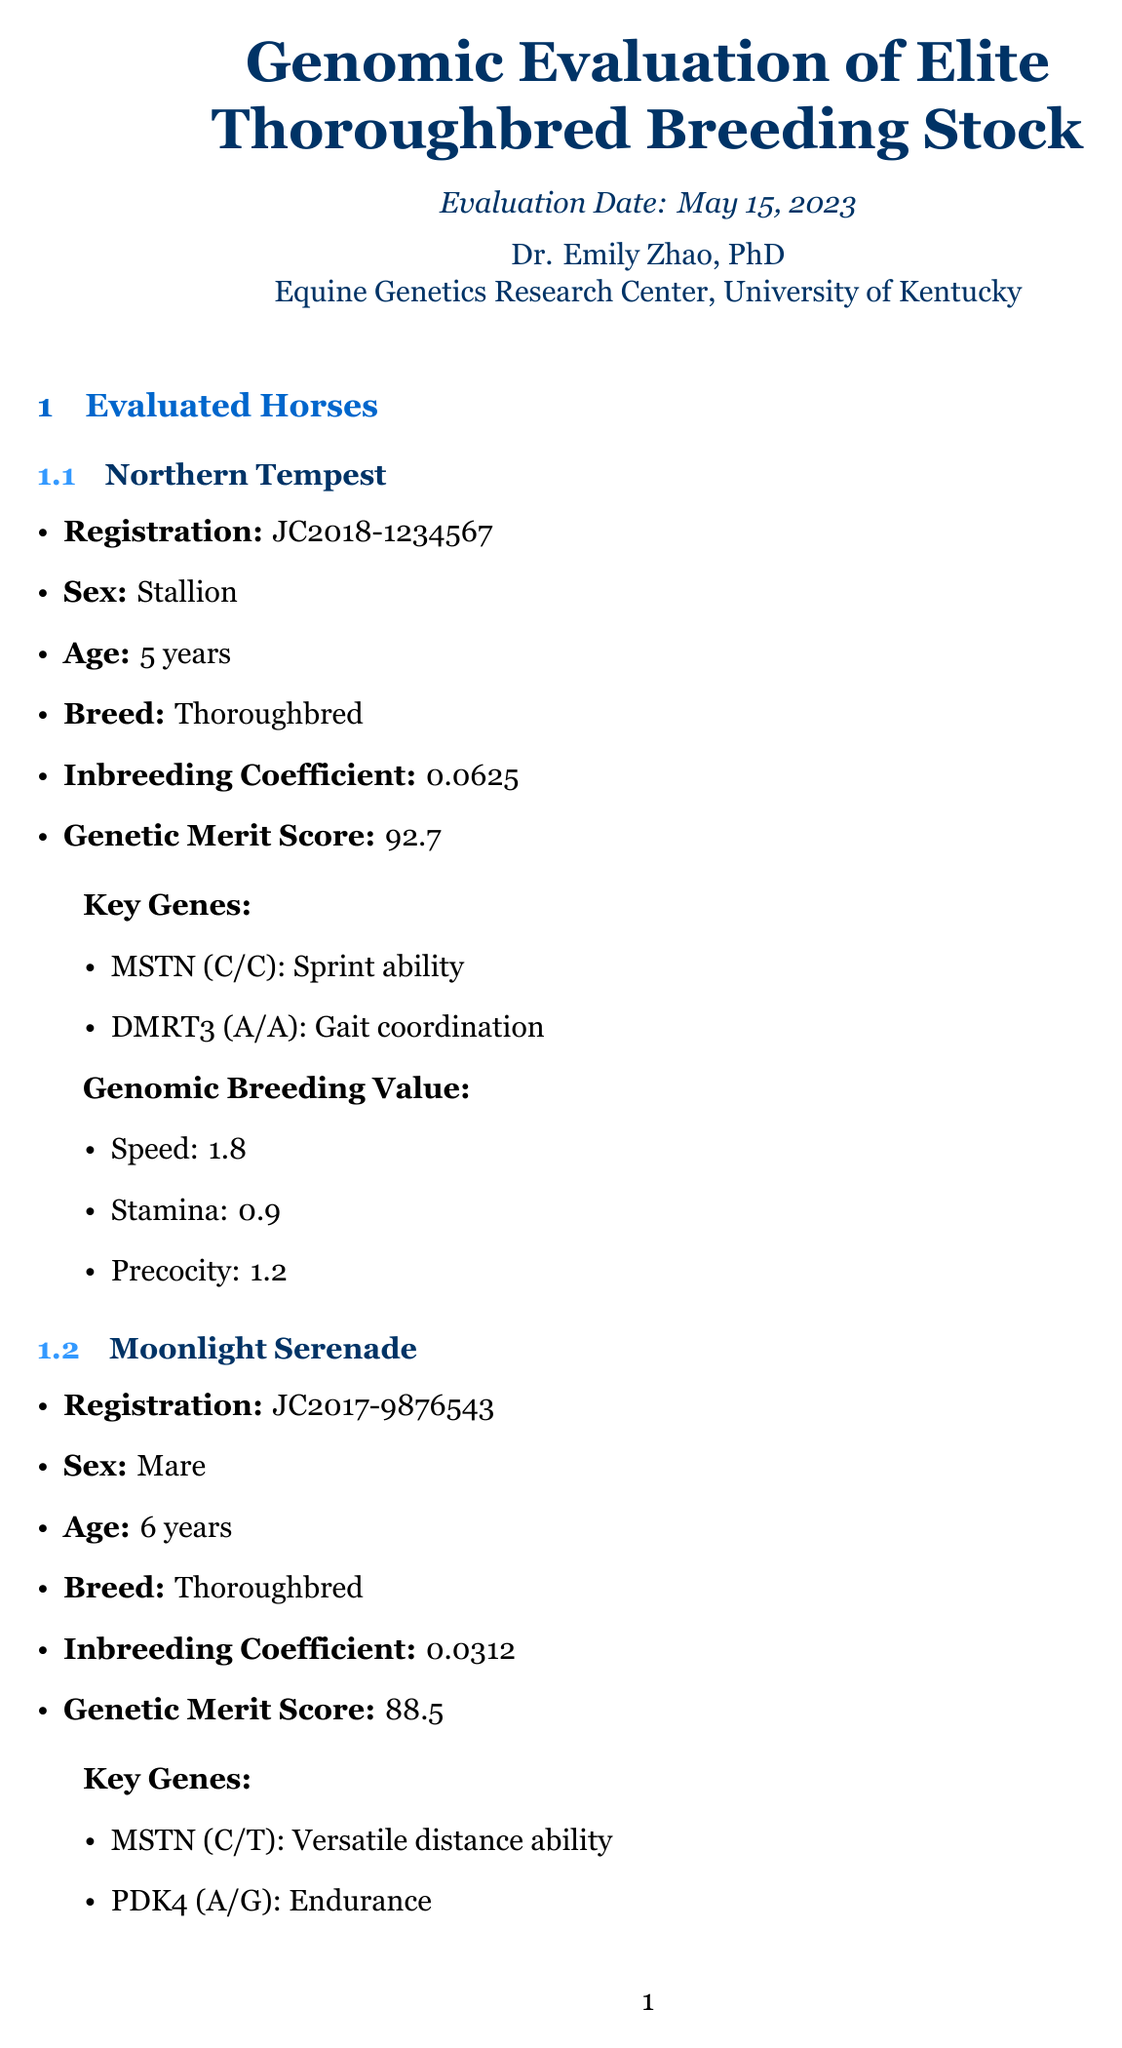What is the title of the report? The title of the report is clearly stated at the beginning of the document.
Answer: Genomic Evaluation of Elite Thoroughbred Breeding Stock Who conducted the evaluation? The analyst's name is listed in the document as responsible for the evaluation.
Answer: Dr. Emily Zhao, PhD What is the inbreeding coefficient of Northern Tempest? The inbreeding coefficient for Northern Tempest is found in the details about the horse.
Answer: 0.0625 What is the expected inbreeding coefficient for the breeding pair? The expected inbreeding coefficient is specified in the breeding recommendations section.
Answer: 0.0156 Which sequencing platform was used? The sequencing platform is identified in the methodology section of the document.
Answer: Illumina NovaSeq 6000 What are the two risk factors associated with the recommended breeding pair? The document outlines specific risks linked to breeding recommendations.
Answer: Potential for osteochondrosis What is the genetic merit score of Moonlight Serenade? The genetic merit score is provided as part of the information about Moonlight Serenade.
Answer: 88.5 What genetic defects were screened in the horses? The screened conditions for genetic defects are listed in the genetic defect screening section.
Answer: Hereditary Equine Regional Dermal Asthenia (HERDA), Hyperkalemic Periodic Paralysis (HYPP), Lethal White Overo Syndrome (LWOS) What is one future consideration mentioned in the report? Future considerations are detailed towards the end of the document, indicating what actions to take next.
Answer: Implement genomic selection strategies 